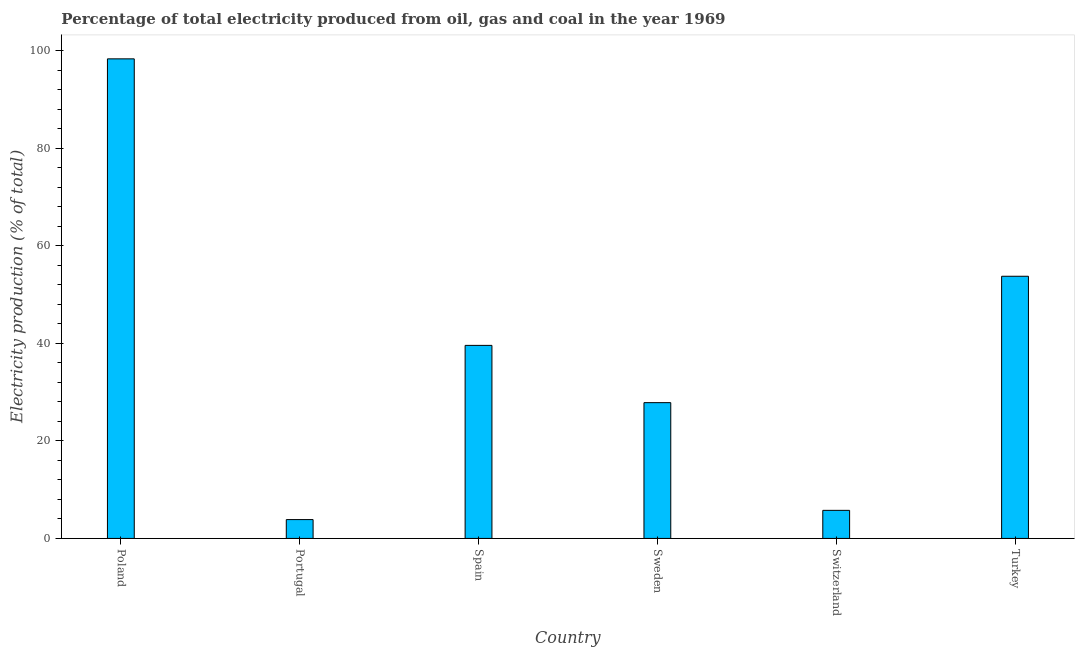Does the graph contain any zero values?
Offer a very short reply. No. What is the title of the graph?
Your response must be concise. Percentage of total electricity produced from oil, gas and coal in the year 1969. What is the label or title of the Y-axis?
Provide a short and direct response. Electricity production (% of total). What is the electricity production in Portugal?
Your response must be concise. 3.87. Across all countries, what is the maximum electricity production?
Offer a terse response. 98.37. Across all countries, what is the minimum electricity production?
Ensure brevity in your answer.  3.87. In which country was the electricity production minimum?
Offer a terse response. Portugal. What is the sum of the electricity production?
Your answer should be very brief. 229.21. What is the difference between the electricity production in Portugal and Spain?
Your response must be concise. -35.73. What is the average electricity production per country?
Offer a terse response. 38.2. What is the median electricity production?
Provide a succinct answer. 33.72. In how many countries, is the electricity production greater than 68 %?
Provide a short and direct response. 1. What is the ratio of the electricity production in Portugal to that in Sweden?
Your response must be concise. 0.14. What is the difference between the highest and the second highest electricity production?
Make the answer very short. 44.59. Is the sum of the electricity production in Poland and Sweden greater than the maximum electricity production across all countries?
Offer a very short reply. Yes. What is the difference between the highest and the lowest electricity production?
Give a very brief answer. 94.5. In how many countries, is the electricity production greater than the average electricity production taken over all countries?
Give a very brief answer. 3. How many bars are there?
Give a very brief answer. 6. How many countries are there in the graph?
Give a very brief answer. 6. What is the difference between two consecutive major ticks on the Y-axis?
Keep it short and to the point. 20. Are the values on the major ticks of Y-axis written in scientific E-notation?
Your answer should be very brief. No. What is the Electricity production (% of total) in Poland?
Make the answer very short. 98.37. What is the Electricity production (% of total) of Portugal?
Offer a terse response. 3.87. What is the Electricity production (% of total) in Spain?
Your answer should be compact. 39.6. What is the Electricity production (% of total) in Sweden?
Make the answer very short. 27.85. What is the Electricity production (% of total) of Switzerland?
Make the answer very short. 5.76. What is the Electricity production (% of total) of Turkey?
Give a very brief answer. 53.78. What is the difference between the Electricity production (% of total) in Poland and Portugal?
Your answer should be compact. 94.5. What is the difference between the Electricity production (% of total) in Poland and Spain?
Keep it short and to the point. 58.77. What is the difference between the Electricity production (% of total) in Poland and Sweden?
Your answer should be very brief. 70.52. What is the difference between the Electricity production (% of total) in Poland and Switzerland?
Provide a short and direct response. 92.61. What is the difference between the Electricity production (% of total) in Poland and Turkey?
Give a very brief answer. 44.59. What is the difference between the Electricity production (% of total) in Portugal and Spain?
Your response must be concise. -35.73. What is the difference between the Electricity production (% of total) in Portugal and Sweden?
Your response must be concise. -23.99. What is the difference between the Electricity production (% of total) in Portugal and Switzerland?
Make the answer very short. -1.89. What is the difference between the Electricity production (% of total) in Portugal and Turkey?
Make the answer very short. -49.91. What is the difference between the Electricity production (% of total) in Spain and Sweden?
Your answer should be very brief. 11.74. What is the difference between the Electricity production (% of total) in Spain and Switzerland?
Provide a succinct answer. 33.84. What is the difference between the Electricity production (% of total) in Spain and Turkey?
Ensure brevity in your answer.  -14.18. What is the difference between the Electricity production (% of total) in Sweden and Switzerland?
Ensure brevity in your answer.  22.09. What is the difference between the Electricity production (% of total) in Sweden and Turkey?
Give a very brief answer. -25.93. What is the difference between the Electricity production (% of total) in Switzerland and Turkey?
Offer a very short reply. -48.02. What is the ratio of the Electricity production (% of total) in Poland to that in Portugal?
Keep it short and to the point. 25.45. What is the ratio of the Electricity production (% of total) in Poland to that in Spain?
Your response must be concise. 2.48. What is the ratio of the Electricity production (% of total) in Poland to that in Sweden?
Make the answer very short. 3.53. What is the ratio of the Electricity production (% of total) in Poland to that in Switzerland?
Keep it short and to the point. 17.08. What is the ratio of the Electricity production (% of total) in Poland to that in Turkey?
Provide a short and direct response. 1.83. What is the ratio of the Electricity production (% of total) in Portugal to that in Spain?
Offer a very short reply. 0.1. What is the ratio of the Electricity production (% of total) in Portugal to that in Sweden?
Your answer should be very brief. 0.14. What is the ratio of the Electricity production (% of total) in Portugal to that in Switzerland?
Provide a succinct answer. 0.67. What is the ratio of the Electricity production (% of total) in Portugal to that in Turkey?
Make the answer very short. 0.07. What is the ratio of the Electricity production (% of total) in Spain to that in Sweden?
Offer a very short reply. 1.42. What is the ratio of the Electricity production (% of total) in Spain to that in Switzerland?
Offer a very short reply. 6.88. What is the ratio of the Electricity production (% of total) in Spain to that in Turkey?
Your answer should be compact. 0.74. What is the ratio of the Electricity production (% of total) in Sweden to that in Switzerland?
Offer a terse response. 4.84. What is the ratio of the Electricity production (% of total) in Sweden to that in Turkey?
Offer a terse response. 0.52. What is the ratio of the Electricity production (% of total) in Switzerland to that in Turkey?
Your answer should be compact. 0.11. 